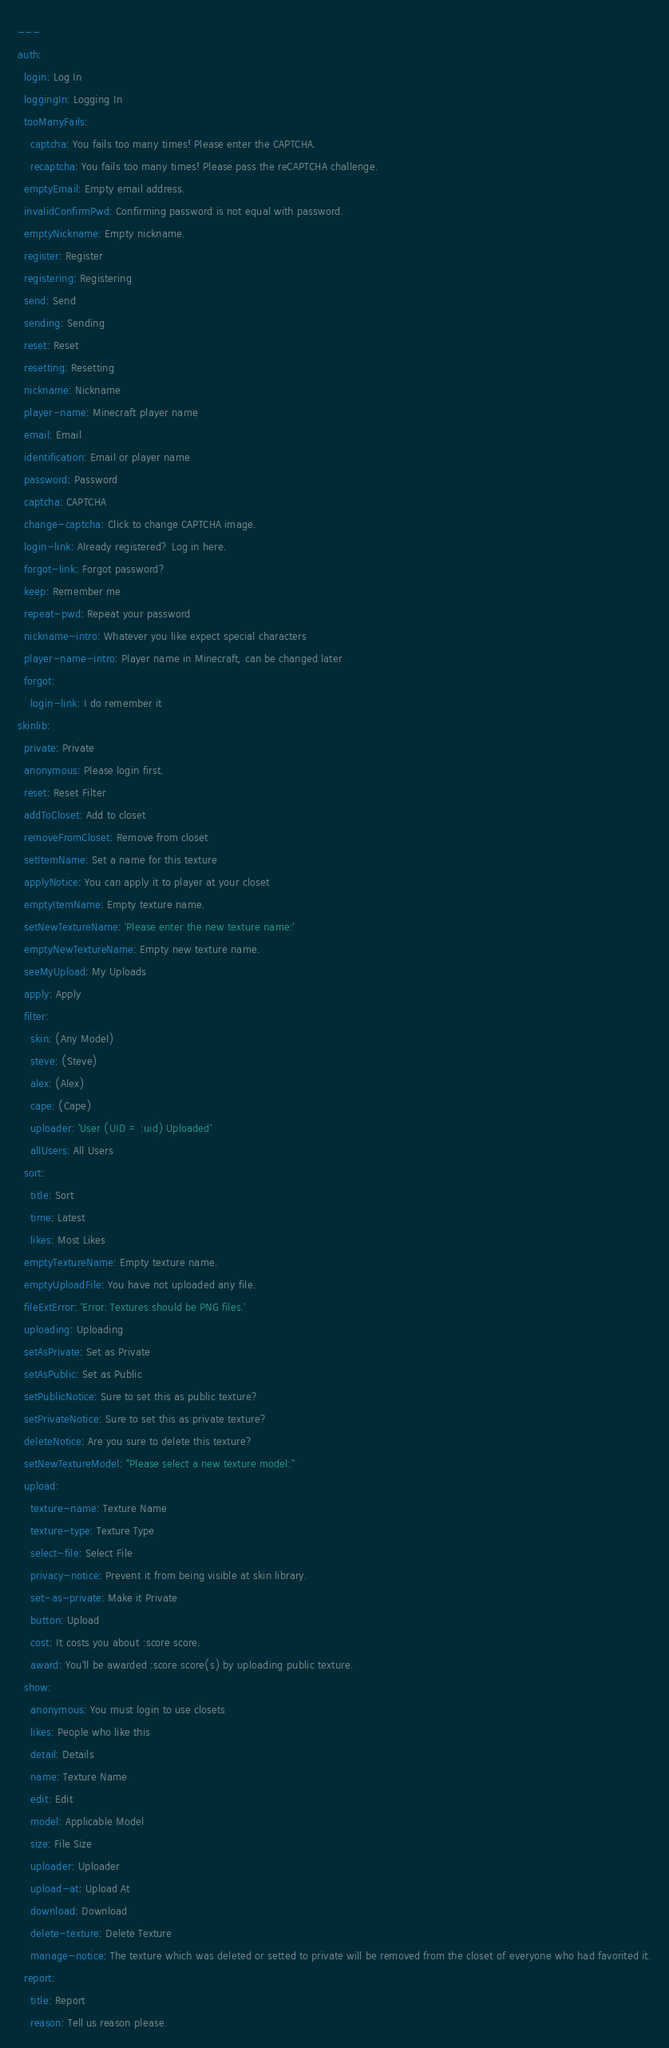<code> <loc_0><loc_0><loc_500><loc_500><_YAML_>---
auth:
  login: Log In
  loggingIn: Logging In
  tooManyFails:
    captcha: You fails too many times! Please enter the CAPTCHA.
    recaptcha: You fails too many times! Please pass the reCAPTCHA challenge.
  emptyEmail: Empty email address.
  invalidConfirmPwd: Confirming password is not equal with password.
  emptyNickname: Empty nickname.
  register: Register
  registering: Registering
  send: Send
  sending: Sending
  reset: Reset
  resetting: Resetting
  nickname: Nickname
  player-name: Minecraft player name
  email: Email
  identification: Email or player name
  password: Password
  captcha: CAPTCHA
  change-captcha: Click to change CAPTCHA image.
  login-link: Already registered? Log in here.
  forgot-link: Forgot password?
  keep: Remember me
  repeat-pwd: Repeat your password
  nickname-intro: Whatever you like expect special characters
  player-name-intro: Player name in Minecraft, can be changed later
  forgot:
    login-link: I do remember it
skinlib:
  private: Private
  anonymous: Please login first.
  reset: Reset Filter
  addToCloset: Add to closet
  removeFromCloset: Remove from closet
  setItemName: Set a name for this texture
  applyNotice: You can apply it to player at your closet
  emptyItemName: Empty texture name.
  setNewTextureName: 'Please enter the new texture name:'
  emptyNewTextureName: Empty new texture name.
  seeMyUpload: My Uploads
  apply: Apply
  filter:
    skin: (Any Model)
    steve: (Steve)
    alex: (Alex)
    cape: (Cape)
    uploader: 'User (UID = :uid) Uploaded'
    allUsers: All Users
  sort:
    title: Sort
    time: Latest
    likes: Most Likes
  emptyTextureName: Empty texture name.
  emptyUploadFile: You have not uploaded any file.
  fileExtError: 'Error: Textures should be PNG files.'
  uploading: Uploading
  setAsPrivate: Set as Private
  setAsPublic: Set as Public
  setPublicNotice: Sure to set this as public texture?
  setPrivateNotice: Sure to set this as private texture?
  deleteNotice: Are you sure to delete this texture?
  setNewTextureModel: "Please select a new texture model:"
  upload:
    texture-name: Texture Name
    texture-type: Texture Type
    select-file: Select File
    privacy-notice: Prevent it from being visible at skin library.
    set-as-private: Make it Private
    button: Upload
    cost: It costs you about :score score.
    award: You'll be awarded :score score(s) by uploading public texture.
  show:
    anonymous: You must login to use closets
    likes: People who like this
    detail: Details
    name: Texture Name
    edit: Edit
    model: Applicable Model
    size: File Size
    uploader: Uploader
    upload-at: Upload At
    download: Download
    delete-texture: Delete Texture
    manage-notice: The texture which was deleted or setted to private will be removed from the closet of everyone who had favorited it.
  report:
    title: Report
    reason: Tell us reason please.</code> 